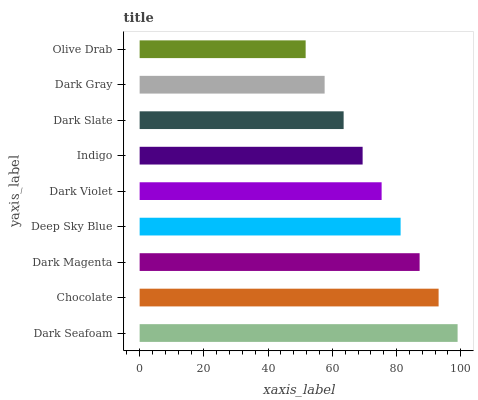Is Olive Drab the minimum?
Answer yes or no. Yes. Is Dark Seafoam the maximum?
Answer yes or no. Yes. Is Chocolate the minimum?
Answer yes or no. No. Is Chocolate the maximum?
Answer yes or no. No. Is Dark Seafoam greater than Chocolate?
Answer yes or no. Yes. Is Chocolate less than Dark Seafoam?
Answer yes or no. Yes. Is Chocolate greater than Dark Seafoam?
Answer yes or no. No. Is Dark Seafoam less than Chocolate?
Answer yes or no. No. Is Dark Violet the high median?
Answer yes or no. Yes. Is Dark Violet the low median?
Answer yes or no. Yes. Is Chocolate the high median?
Answer yes or no. No. Is Indigo the low median?
Answer yes or no. No. 